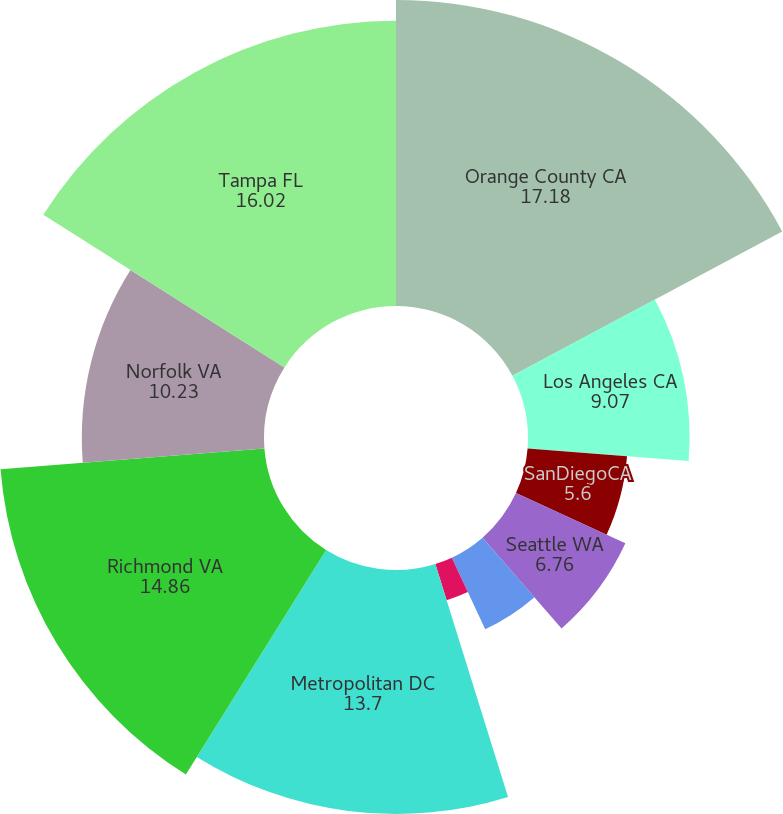Convert chart to OTSL. <chart><loc_0><loc_0><loc_500><loc_500><pie_chart><fcel>Orange County CA<fcel>Los Angeles CA<fcel>SanDiegoCA<fcel>Seattle WA<fcel>Sacramento CA<fcel>Portland OR<fcel>Metropolitan DC<fcel>Richmond VA<fcel>Norfolk VA<fcel>Tampa FL<nl><fcel>17.18%<fcel>9.07%<fcel>5.6%<fcel>6.76%<fcel>4.44%<fcel>2.13%<fcel>13.7%<fcel>14.86%<fcel>10.23%<fcel>16.02%<nl></chart> 